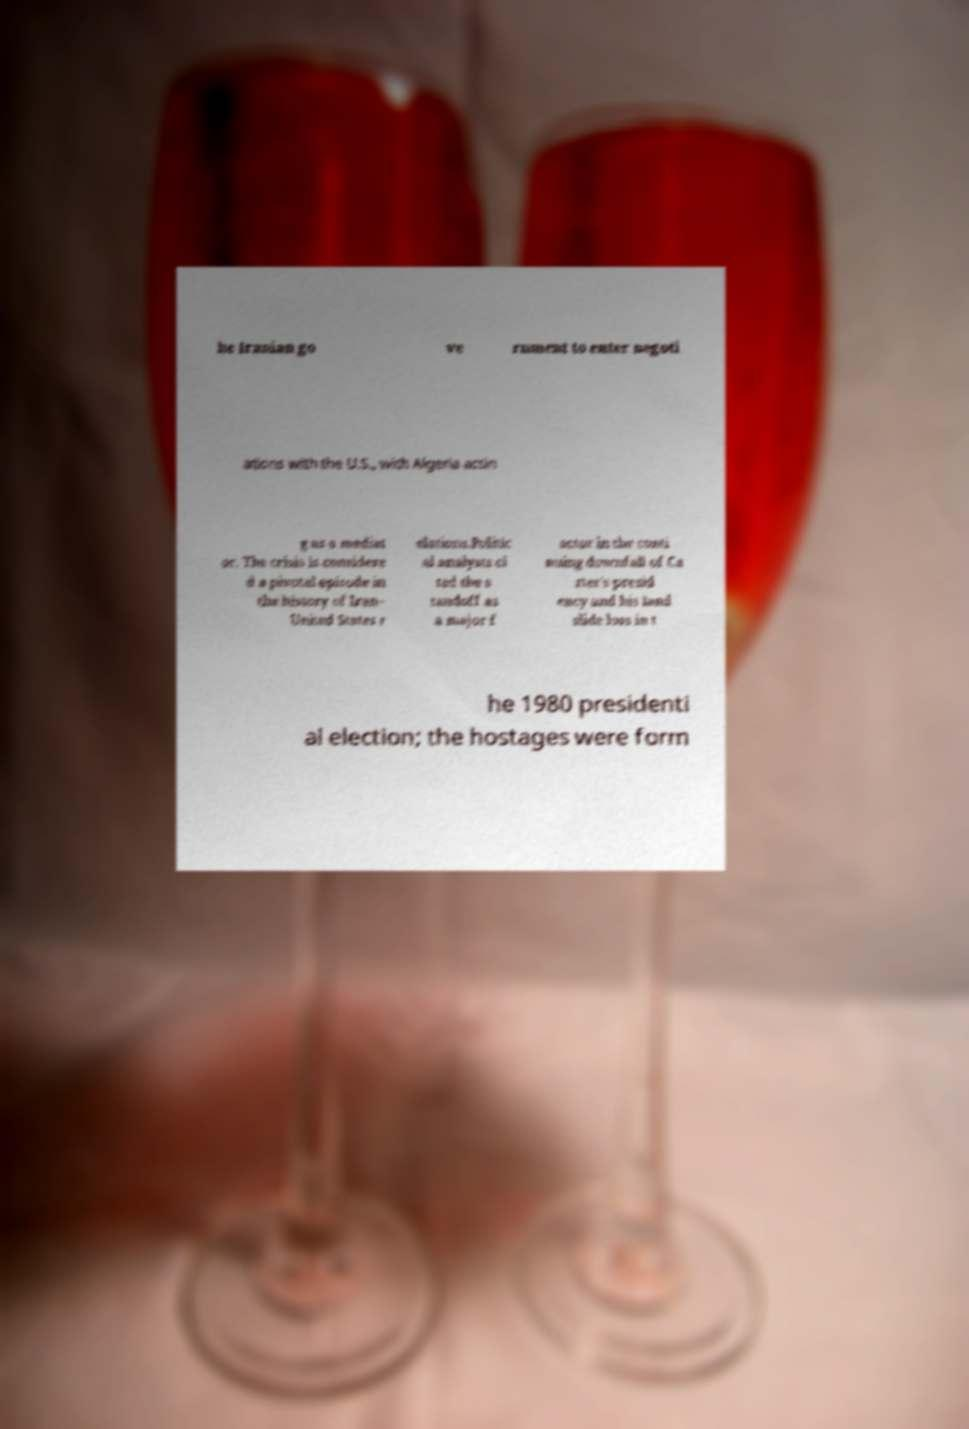What messages or text are displayed in this image? I need them in a readable, typed format. he Iranian go ve rnment to enter negoti ations with the U.S., with Algeria actin g as a mediat or. The crisis is considere d a pivotal episode in the history of Iran– United States r elations.Politic al analysts ci ted the s tandoff as a major f actor in the conti nuing downfall of Ca rter's presid ency and his land slide loss in t he 1980 presidenti al election; the hostages were form 